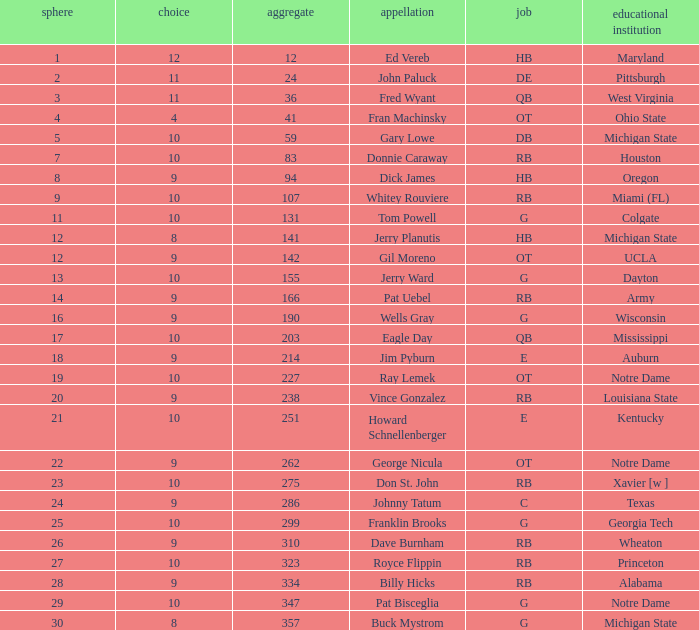What is the overall pick number for a draft pick smaller than 9, named buck mystrom from Michigan State college? 357.0. 